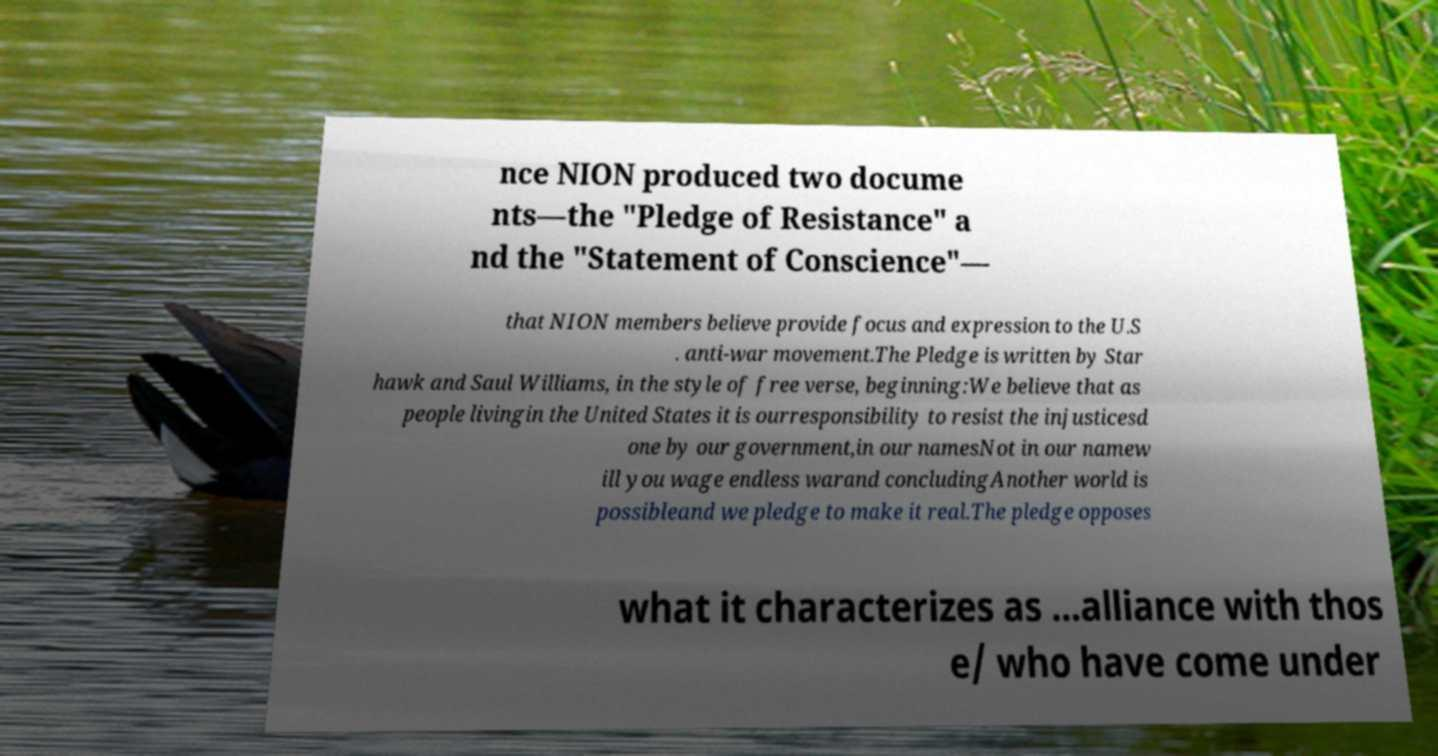Please read and relay the text visible in this image. What does it say? nce NION produced two docume nts—the "Pledge of Resistance" a nd the "Statement of Conscience"— that NION members believe provide focus and expression to the U.S . anti-war movement.The Pledge is written by Star hawk and Saul Williams, in the style of free verse, beginning:We believe that as people livingin the United States it is ourresponsibility to resist the injusticesd one by our government,in our namesNot in our namew ill you wage endless warand concludingAnother world is possibleand we pledge to make it real.The pledge opposes what it characterizes as ...alliance with thos e/ who have come under 